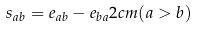Convert formula to latex. <formula><loc_0><loc_0><loc_500><loc_500>s _ { a b } = e _ { a b } - e _ { b a } 2 c m ( a > b )</formula> 